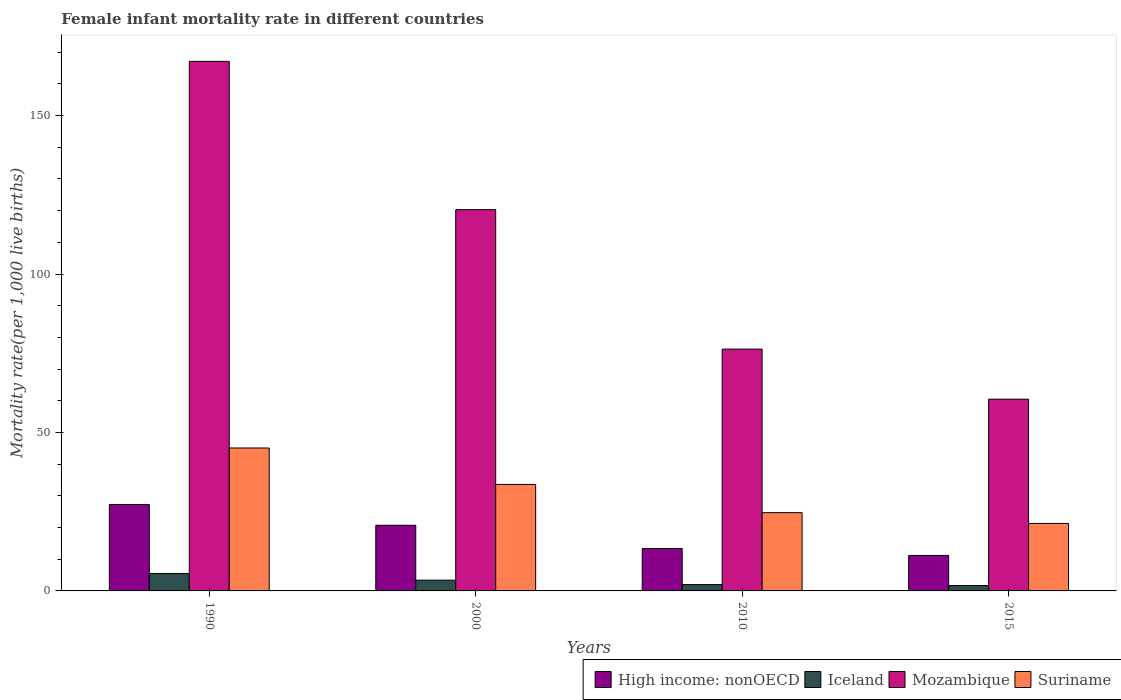How many groups of bars are there?
Your response must be concise. 4. Are the number of bars per tick equal to the number of legend labels?
Give a very brief answer. Yes. Are the number of bars on each tick of the X-axis equal?
Ensure brevity in your answer.  Yes. How many bars are there on the 4th tick from the left?
Your answer should be very brief. 4. How many bars are there on the 1st tick from the right?
Your response must be concise. 4. What is the label of the 2nd group of bars from the left?
Make the answer very short. 2000. What is the female infant mortality rate in High income: nonOECD in 2000?
Make the answer very short. 20.71. Across all years, what is the maximum female infant mortality rate in Mozambique?
Offer a terse response. 167.1. Across all years, what is the minimum female infant mortality rate in High income: nonOECD?
Offer a very short reply. 11.2. In which year was the female infant mortality rate in Iceland maximum?
Keep it short and to the point. 1990. In which year was the female infant mortality rate in Iceland minimum?
Provide a short and direct response. 2015. What is the total female infant mortality rate in Suriname in the graph?
Offer a terse response. 124.7. What is the difference between the female infant mortality rate in High income: nonOECD in 1990 and that in 2015?
Make the answer very short. 16.07. What is the difference between the female infant mortality rate in Iceland in 2000 and the female infant mortality rate in Suriname in 1990?
Your answer should be compact. -41.7. What is the average female infant mortality rate in High income: nonOECD per year?
Ensure brevity in your answer.  18.14. In the year 2015, what is the difference between the female infant mortality rate in Mozambique and female infant mortality rate in Suriname?
Your answer should be very brief. 39.2. What is the ratio of the female infant mortality rate in Mozambique in 2010 to that in 2015?
Your response must be concise. 1.26. Is the female infant mortality rate in Mozambique in 2010 less than that in 2015?
Give a very brief answer. No. Is the difference between the female infant mortality rate in Mozambique in 2010 and 2015 greater than the difference between the female infant mortality rate in Suriname in 2010 and 2015?
Keep it short and to the point. Yes. What is the difference between the highest and the second highest female infant mortality rate in Mozambique?
Your answer should be compact. 46.8. What does the 4th bar from the left in 1990 represents?
Offer a terse response. Suriname. What does the 1st bar from the right in 2015 represents?
Give a very brief answer. Suriname. Is it the case that in every year, the sum of the female infant mortality rate in Suriname and female infant mortality rate in Mozambique is greater than the female infant mortality rate in High income: nonOECD?
Keep it short and to the point. Yes. How many bars are there?
Your response must be concise. 16. How many years are there in the graph?
Offer a very short reply. 4. What is the difference between two consecutive major ticks on the Y-axis?
Provide a short and direct response. 50. Does the graph contain any zero values?
Your answer should be compact. No. How many legend labels are there?
Your answer should be compact. 4. What is the title of the graph?
Your response must be concise. Female infant mortality rate in different countries. What is the label or title of the Y-axis?
Your response must be concise. Mortality rate(per 1,0 live births). What is the Mortality rate(per 1,000 live births) in High income: nonOECD in 1990?
Provide a short and direct response. 27.26. What is the Mortality rate(per 1,000 live births) of Mozambique in 1990?
Offer a terse response. 167.1. What is the Mortality rate(per 1,000 live births) of Suriname in 1990?
Your answer should be compact. 45.1. What is the Mortality rate(per 1,000 live births) of High income: nonOECD in 2000?
Provide a short and direct response. 20.71. What is the Mortality rate(per 1,000 live births) of Mozambique in 2000?
Your response must be concise. 120.3. What is the Mortality rate(per 1,000 live births) in Suriname in 2000?
Offer a terse response. 33.6. What is the Mortality rate(per 1,000 live births) in High income: nonOECD in 2010?
Offer a terse response. 13.39. What is the Mortality rate(per 1,000 live births) in Iceland in 2010?
Offer a very short reply. 2. What is the Mortality rate(per 1,000 live births) in Mozambique in 2010?
Ensure brevity in your answer.  76.3. What is the Mortality rate(per 1,000 live births) in Suriname in 2010?
Keep it short and to the point. 24.7. What is the Mortality rate(per 1,000 live births) in High income: nonOECD in 2015?
Your response must be concise. 11.2. What is the Mortality rate(per 1,000 live births) of Iceland in 2015?
Provide a succinct answer. 1.7. What is the Mortality rate(per 1,000 live births) of Mozambique in 2015?
Give a very brief answer. 60.5. What is the Mortality rate(per 1,000 live births) of Suriname in 2015?
Make the answer very short. 21.3. Across all years, what is the maximum Mortality rate(per 1,000 live births) in High income: nonOECD?
Make the answer very short. 27.26. Across all years, what is the maximum Mortality rate(per 1,000 live births) in Iceland?
Offer a very short reply. 5.5. Across all years, what is the maximum Mortality rate(per 1,000 live births) in Mozambique?
Give a very brief answer. 167.1. Across all years, what is the maximum Mortality rate(per 1,000 live births) of Suriname?
Keep it short and to the point. 45.1. Across all years, what is the minimum Mortality rate(per 1,000 live births) of High income: nonOECD?
Keep it short and to the point. 11.2. Across all years, what is the minimum Mortality rate(per 1,000 live births) of Mozambique?
Ensure brevity in your answer.  60.5. Across all years, what is the minimum Mortality rate(per 1,000 live births) of Suriname?
Make the answer very short. 21.3. What is the total Mortality rate(per 1,000 live births) in High income: nonOECD in the graph?
Provide a short and direct response. 72.56. What is the total Mortality rate(per 1,000 live births) of Mozambique in the graph?
Offer a very short reply. 424.2. What is the total Mortality rate(per 1,000 live births) of Suriname in the graph?
Keep it short and to the point. 124.7. What is the difference between the Mortality rate(per 1,000 live births) of High income: nonOECD in 1990 and that in 2000?
Your response must be concise. 6.55. What is the difference between the Mortality rate(per 1,000 live births) in Iceland in 1990 and that in 2000?
Ensure brevity in your answer.  2.1. What is the difference between the Mortality rate(per 1,000 live births) in Mozambique in 1990 and that in 2000?
Offer a terse response. 46.8. What is the difference between the Mortality rate(per 1,000 live births) of High income: nonOECD in 1990 and that in 2010?
Give a very brief answer. 13.88. What is the difference between the Mortality rate(per 1,000 live births) in Iceland in 1990 and that in 2010?
Keep it short and to the point. 3.5. What is the difference between the Mortality rate(per 1,000 live births) of Mozambique in 1990 and that in 2010?
Offer a terse response. 90.8. What is the difference between the Mortality rate(per 1,000 live births) of Suriname in 1990 and that in 2010?
Your answer should be very brief. 20.4. What is the difference between the Mortality rate(per 1,000 live births) of High income: nonOECD in 1990 and that in 2015?
Offer a terse response. 16.07. What is the difference between the Mortality rate(per 1,000 live births) in Iceland in 1990 and that in 2015?
Provide a short and direct response. 3.8. What is the difference between the Mortality rate(per 1,000 live births) in Mozambique in 1990 and that in 2015?
Offer a terse response. 106.6. What is the difference between the Mortality rate(per 1,000 live births) in Suriname in 1990 and that in 2015?
Give a very brief answer. 23.8. What is the difference between the Mortality rate(per 1,000 live births) of High income: nonOECD in 2000 and that in 2010?
Provide a succinct answer. 7.33. What is the difference between the Mortality rate(per 1,000 live births) of Iceland in 2000 and that in 2010?
Provide a short and direct response. 1.4. What is the difference between the Mortality rate(per 1,000 live births) of Suriname in 2000 and that in 2010?
Make the answer very short. 8.9. What is the difference between the Mortality rate(per 1,000 live births) in High income: nonOECD in 2000 and that in 2015?
Offer a terse response. 9.52. What is the difference between the Mortality rate(per 1,000 live births) in Iceland in 2000 and that in 2015?
Provide a succinct answer. 1.7. What is the difference between the Mortality rate(per 1,000 live births) of Mozambique in 2000 and that in 2015?
Your response must be concise. 59.8. What is the difference between the Mortality rate(per 1,000 live births) of Suriname in 2000 and that in 2015?
Ensure brevity in your answer.  12.3. What is the difference between the Mortality rate(per 1,000 live births) of High income: nonOECD in 2010 and that in 2015?
Give a very brief answer. 2.19. What is the difference between the Mortality rate(per 1,000 live births) of Iceland in 2010 and that in 2015?
Your response must be concise. 0.3. What is the difference between the Mortality rate(per 1,000 live births) in Mozambique in 2010 and that in 2015?
Provide a succinct answer. 15.8. What is the difference between the Mortality rate(per 1,000 live births) in High income: nonOECD in 1990 and the Mortality rate(per 1,000 live births) in Iceland in 2000?
Offer a terse response. 23.86. What is the difference between the Mortality rate(per 1,000 live births) in High income: nonOECD in 1990 and the Mortality rate(per 1,000 live births) in Mozambique in 2000?
Offer a very short reply. -93.04. What is the difference between the Mortality rate(per 1,000 live births) in High income: nonOECD in 1990 and the Mortality rate(per 1,000 live births) in Suriname in 2000?
Provide a short and direct response. -6.34. What is the difference between the Mortality rate(per 1,000 live births) of Iceland in 1990 and the Mortality rate(per 1,000 live births) of Mozambique in 2000?
Give a very brief answer. -114.8. What is the difference between the Mortality rate(per 1,000 live births) of Iceland in 1990 and the Mortality rate(per 1,000 live births) of Suriname in 2000?
Offer a very short reply. -28.1. What is the difference between the Mortality rate(per 1,000 live births) of Mozambique in 1990 and the Mortality rate(per 1,000 live births) of Suriname in 2000?
Make the answer very short. 133.5. What is the difference between the Mortality rate(per 1,000 live births) of High income: nonOECD in 1990 and the Mortality rate(per 1,000 live births) of Iceland in 2010?
Give a very brief answer. 25.26. What is the difference between the Mortality rate(per 1,000 live births) of High income: nonOECD in 1990 and the Mortality rate(per 1,000 live births) of Mozambique in 2010?
Give a very brief answer. -49.04. What is the difference between the Mortality rate(per 1,000 live births) of High income: nonOECD in 1990 and the Mortality rate(per 1,000 live births) of Suriname in 2010?
Offer a very short reply. 2.56. What is the difference between the Mortality rate(per 1,000 live births) in Iceland in 1990 and the Mortality rate(per 1,000 live births) in Mozambique in 2010?
Give a very brief answer. -70.8. What is the difference between the Mortality rate(per 1,000 live births) of Iceland in 1990 and the Mortality rate(per 1,000 live births) of Suriname in 2010?
Your response must be concise. -19.2. What is the difference between the Mortality rate(per 1,000 live births) in Mozambique in 1990 and the Mortality rate(per 1,000 live births) in Suriname in 2010?
Your answer should be compact. 142.4. What is the difference between the Mortality rate(per 1,000 live births) in High income: nonOECD in 1990 and the Mortality rate(per 1,000 live births) in Iceland in 2015?
Your answer should be compact. 25.56. What is the difference between the Mortality rate(per 1,000 live births) in High income: nonOECD in 1990 and the Mortality rate(per 1,000 live births) in Mozambique in 2015?
Offer a very short reply. -33.24. What is the difference between the Mortality rate(per 1,000 live births) in High income: nonOECD in 1990 and the Mortality rate(per 1,000 live births) in Suriname in 2015?
Provide a succinct answer. 5.96. What is the difference between the Mortality rate(per 1,000 live births) in Iceland in 1990 and the Mortality rate(per 1,000 live births) in Mozambique in 2015?
Give a very brief answer. -55. What is the difference between the Mortality rate(per 1,000 live births) of Iceland in 1990 and the Mortality rate(per 1,000 live births) of Suriname in 2015?
Provide a short and direct response. -15.8. What is the difference between the Mortality rate(per 1,000 live births) in Mozambique in 1990 and the Mortality rate(per 1,000 live births) in Suriname in 2015?
Keep it short and to the point. 145.8. What is the difference between the Mortality rate(per 1,000 live births) of High income: nonOECD in 2000 and the Mortality rate(per 1,000 live births) of Iceland in 2010?
Offer a very short reply. 18.71. What is the difference between the Mortality rate(per 1,000 live births) of High income: nonOECD in 2000 and the Mortality rate(per 1,000 live births) of Mozambique in 2010?
Provide a succinct answer. -55.59. What is the difference between the Mortality rate(per 1,000 live births) in High income: nonOECD in 2000 and the Mortality rate(per 1,000 live births) in Suriname in 2010?
Offer a terse response. -3.99. What is the difference between the Mortality rate(per 1,000 live births) in Iceland in 2000 and the Mortality rate(per 1,000 live births) in Mozambique in 2010?
Provide a succinct answer. -72.9. What is the difference between the Mortality rate(per 1,000 live births) of Iceland in 2000 and the Mortality rate(per 1,000 live births) of Suriname in 2010?
Offer a very short reply. -21.3. What is the difference between the Mortality rate(per 1,000 live births) in Mozambique in 2000 and the Mortality rate(per 1,000 live births) in Suriname in 2010?
Provide a short and direct response. 95.6. What is the difference between the Mortality rate(per 1,000 live births) in High income: nonOECD in 2000 and the Mortality rate(per 1,000 live births) in Iceland in 2015?
Your response must be concise. 19.01. What is the difference between the Mortality rate(per 1,000 live births) of High income: nonOECD in 2000 and the Mortality rate(per 1,000 live births) of Mozambique in 2015?
Ensure brevity in your answer.  -39.79. What is the difference between the Mortality rate(per 1,000 live births) of High income: nonOECD in 2000 and the Mortality rate(per 1,000 live births) of Suriname in 2015?
Provide a short and direct response. -0.59. What is the difference between the Mortality rate(per 1,000 live births) in Iceland in 2000 and the Mortality rate(per 1,000 live births) in Mozambique in 2015?
Offer a very short reply. -57.1. What is the difference between the Mortality rate(per 1,000 live births) in Iceland in 2000 and the Mortality rate(per 1,000 live births) in Suriname in 2015?
Provide a short and direct response. -17.9. What is the difference between the Mortality rate(per 1,000 live births) in High income: nonOECD in 2010 and the Mortality rate(per 1,000 live births) in Iceland in 2015?
Your answer should be compact. 11.69. What is the difference between the Mortality rate(per 1,000 live births) of High income: nonOECD in 2010 and the Mortality rate(per 1,000 live births) of Mozambique in 2015?
Keep it short and to the point. -47.11. What is the difference between the Mortality rate(per 1,000 live births) of High income: nonOECD in 2010 and the Mortality rate(per 1,000 live births) of Suriname in 2015?
Your answer should be compact. -7.91. What is the difference between the Mortality rate(per 1,000 live births) in Iceland in 2010 and the Mortality rate(per 1,000 live births) in Mozambique in 2015?
Your response must be concise. -58.5. What is the difference between the Mortality rate(per 1,000 live births) of Iceland in 2010 and the Mortality rate(per 1,000 live births) of Suriname in 2015?
Ensure brevity in your answer.  -19.3. What is the average Mortality rate(per 1,000 live births) in High income: nonOECD per year?
Make the answer very short. 18.14. What is the average Mortality rate(per 1,000 live births) in Iceland per year?
Provide a succinct answer. 3.15. What is the average Mortality rate(per 1,000 live births) of Mozambique per year?
Give a very brief answer. 106.05. What is the average Mortality rate(per 1,000 live births) of Suriname per year?
Your answer should be very brief. 31.18. In the year 1990, what is the difference between the Mortality rate(per 1,000 live births) in High income: nonOECD and Mortality rate(per 1,000 live births) in Iceland?
Offer a very short reply. 21.76. In the year 1990, what is the difference between the Mortality rate(per 1,000 live births) of High income: nonOECD and Mortality rate(per 1,000 live births) of Mozambique?
Make the answer very short. -139.84. In the year 1990, what is the difference between the Mortality rate(per 1,000 live births) in High income: nonOECD and Mortality rate(per 1,000 live births) in Suriname?
Make the answer very short. -17.84. In the year 1990, what is the difference between the Mortality rate(per 1,000 live births) of Iceland and Mortality rate(per 1,000 live births) of Mozambique?
Provide a succinct answer. -161.6. In the year 1990, what is the difference between the Mortality rate(per 1,000 live births) in Iceland and Mortality rate(per 1,000 live births) in Suriname?
Your answer should be compact. -39.6. In the year 1990, what is the difference between the Mortality rate(per 1,000 live births) in Mozambique and Mortality rate(per 1,000 live births) in Suriname?
Keep it short and to the point. 122. In the year 2000, what is the difference between the Mortality rate(per 1,000 live births) in High income: nonOECD and Mortality rate(per 1,000 live births) in Iceland?
Give a very brief answer. 17.31. In the year 2000, what is the difference between the Mortality rate(per 1,000 live births) in High income: nonOECD and Mortality rate(per 1,000 live births) in Mozambique?
Provide a succinct answer. -99.59. In the year 2000, what is the difference between the Mortality rate(per 1,000 live births) in High income: nonOECD and Mortality rate(per 1,000 live births) in Suriname?
Make the answer very short. -12.89. In the year 2000, what is the difference between the Mortality rate(per 1,000 live births) of Iceland and Mortality rate(per 1,000 live births) of Mozambique?
Provide a short and direct response. -116.9. In the year 2000, what is the difference between the Mortality rate(per 1,000 live births) in Iceland and Mortality rate(per 1,000 live births) in Suriname?
Give a very brief answer. -30.2. In the year 2000, what is the difference between the Mortality rate(per 1,000 live births) of Mozambique and Mortality rate(per 1,000 live births) of Suriname?
Make the answer very short. 86.7. In the year 2010, what is the difference between the Mortality rate(per 1,000 live births) in High income: nonOECD and Mortality rate(per 1,000 live births) in Iceland?
Provide a short and direct response. 11.39. In the year 2010, what is the difference between the Mortality rate(per 1,000 live births) in High income: nonOECD and Mortality rate(per 1,000 live births) in Mozambique?
Your response must be concise. -62.91. In the year 2010, what is the difference between the Mortality rate(per 1,000 live births) of High income: nonOECD and Mortality rate(per 1,000 live births) of Suriname?
Your response must be concise. -11.31. In the year 2010, what is the difference between the Mortality rate(per 1,000 live births) in Iceland and Mortality rate(per 1,000 live births) in Mozambique?
Offer a terse response. -74.3. In the year 2010, what is the difference between the Mortality rate(per 1,000 live births) of Iceland and Mortality rate(per 1,000 live births) of Suriname?
Provide a short and direct response. -22.7. In the year 2010, what is the difference between the Mortality rate(per 1,000 live births) in Mozambique and Mortality rate(per 1,000 live births) in Suriname?
Offer a very short reply. 51.6. In the year 2015, what is the difference between the Mortality rate(per 1,000 live births) of High income: nonOECD and Mortality rate(per 1,000 live births) of Iceland?
Provide a succinct answer. 9.5. In the year 2015, what is the difference between the Mortality rate(per 1,000 live births) of High income: nonOECD and Mortality rate(per 1,000 live births) of Mozambique?
Your response must be concise. -49.3. In the year 2015, what is the difference between the Mortality rate(per 1,000 live births) of High income: nonOECD and Mortality rate(per 1,000 live births) of Suriname?
Keep it short and to the point. -10.1. In the year 2015, what is the difference between the Mortality rate(per 1,000 live births) in Iceland and Mortality rate(per 1,000 live births) in Mozambique?
Provide a short and direct response. -58.8. In the year 2015, what is the difference between the Mortality rate(per 1,000 live births) of Iceland and Mortality rate(per 1,000 live births) of Suriname?
Offer a terse response. -19.6. In the year 2015, what is the difference between the Mortality rate(per 1,000 live births) in Mozambique and Mortality rate(per 1,000 live births) in Suriname?
Keep it short and to the point. 39.2. What is the ratio of the Mortality rate(per 1,000 live births) in High income: nonOECD in 1990 to that in 2000?
Offer a very short reply. 1.32. What is the ratio of the Mortality rate(per 1,000 live births) in Iceland in 1990 to that in 2000?
Give a very brief answer. 1.62. What is the ratio of the Mortality rate(per 1,000 live births) of Mozambique in 1990 to that in 2000?
Ensure brevity in your answer.  1.39. What is the ratio of the Mortality rate(per 1,000 live births) of Suriname in 1990 to that in 2000?
Keep it short and to the point. 1.34. What is the ratio of the Mortality rate(per 1,000 live births) in High income: nonOECD in 1990 to that in 2010?
Make the answer very short. 2.04. What is the ratio of the Mortality rate(per 1,000 live births) in Iceland in 1990 to that in 2010?
Your answer should be very brief. 2.75. What is the ratio of the Mortality rate(per 1,000 live births) in Mozambique in 1990 to that in 2010?
Your response must be concise. 2.19. What is the ratio of the Mortality rate(per 1,000 live births) of Suriname in 1990 to that in 2010?
Offer a very short reply. 1.83. What is the ratio of the Mortality rate(per 1,000 live births) in High income: nonOECD in 1990 to that in 2015?
Your answer should be very brief. 2.44. What is the ratio of the Mortality rate(per 1,000 live births) in Iceland in 1990 to that in 2015?
Offer a terse response. 3.24. What is the ratio of the Mortality rate(per 1,000 live births) in Mozambique in 1990 to that in 2015?
Ensure brevity in your answer.  2.76. What is the ratio of the Mortality rate(per 1,000 live births) of Suriname in 1990 to that in 2015?
Keep it short and to the point. 2.12. What is the ratio of the Mortality rate(per 1,000 live births) in High income: nonOECD in 2000 to that in 2010?
Offer a terse response. 1.55. What is the ratio of the Mortality rate(per 1,000 live births) in Iceland in 2000 to that in 2010?
Offer a terse response. 1.7. What is the ratio of the Mortality rate(per 1,000 live births) in Mozambique in 2000 to that in 2010?
Your answer should be very brief. 1.58. What is the ratio of the Mortality rate(per 1,000 live births) of Suriname in 2000 to that in 2010?
Offer a very short reply. 1.36. What is the ratio of the Mortality rate(per 1,000 live births) in High income: nonOECD in 2000 to that in 2015?
Offer a terse response. 1.85. What is the ratio of the Mortality rate(per 1,000 live births) of Iceland in 2000 to that in 2015?
Offer a terse response. 2. What is the ratio of the Mortality rate(per 1,000 live births) in Mozambique in 2000 to that in 2015?
Make the answer very short. 1.99. What is the ratio of the Mortality rate(per 1,000 live births) of Suriname in 2000 to that in 2015?
Your answer should be very brief. 1.58. What is the ratio of the Mortality rate(per 1,000 live births) of High income: nonOECD in 2010 to that in 2015?
Keep it short and to the point. 1.2. What is the ratio of the Mortality rate(per 1,000 live births) in Iceland in 2010 to that in 2015?
Ensure brevity in your answer.  1.18. What is the ratio of the Mortality rate(per 1,000 live births) in Mozambique in 2010 to that in 2015?
Ensure brevity in your answer.  1.26. What is the ratio of the Mortality rate(per 1,000 live births) in Suriname in 2010 to that in 2015?
Your answer should be very brief. 1.16. What is the difference between the highest and the second highest Mortality rate(per 1,000 live births) of High income: nonOECD?
Your answer should be compact. 6.55. What is the difference between the highest and the second highest Mortality rate(per 1,000 live births) of Iceland?
Offer a terse response. 2.1. What is the difference between the highest and the second highest Mortality rate(per 1,000 live births) of Mozambique?
Ensure brevity in your answer.  46.8. What is the difference between the highest and the lowest Mortality rate(per 1,000 live births) in High income: nonOECD?
Your answer should be very brief. 16.07. What is the difference between the highest and the lowest Mortality rate(per 1,000 live births) of Mozambique?
Provide a short and direct response. 106.6. What is the difference between the highest and the lowest Mortality rate(per 1,000 live births) of Suriname?
Your response must be concise. 23.8. 